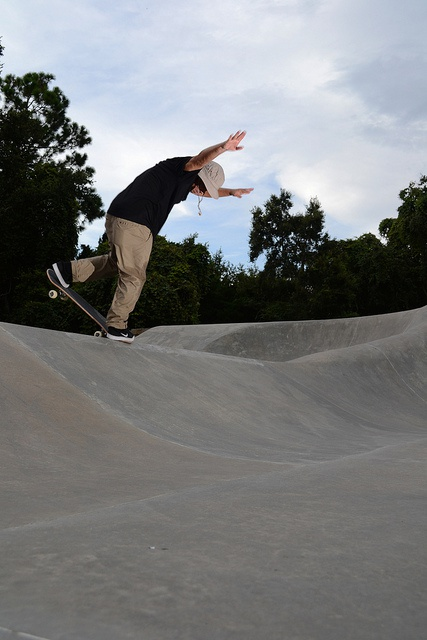Describe the objects in this image and their specific colors. I can see people in lightgray, black, and gray tones and skateboard in lightgray, black, gray, tan, and darkgray tones in this image. 